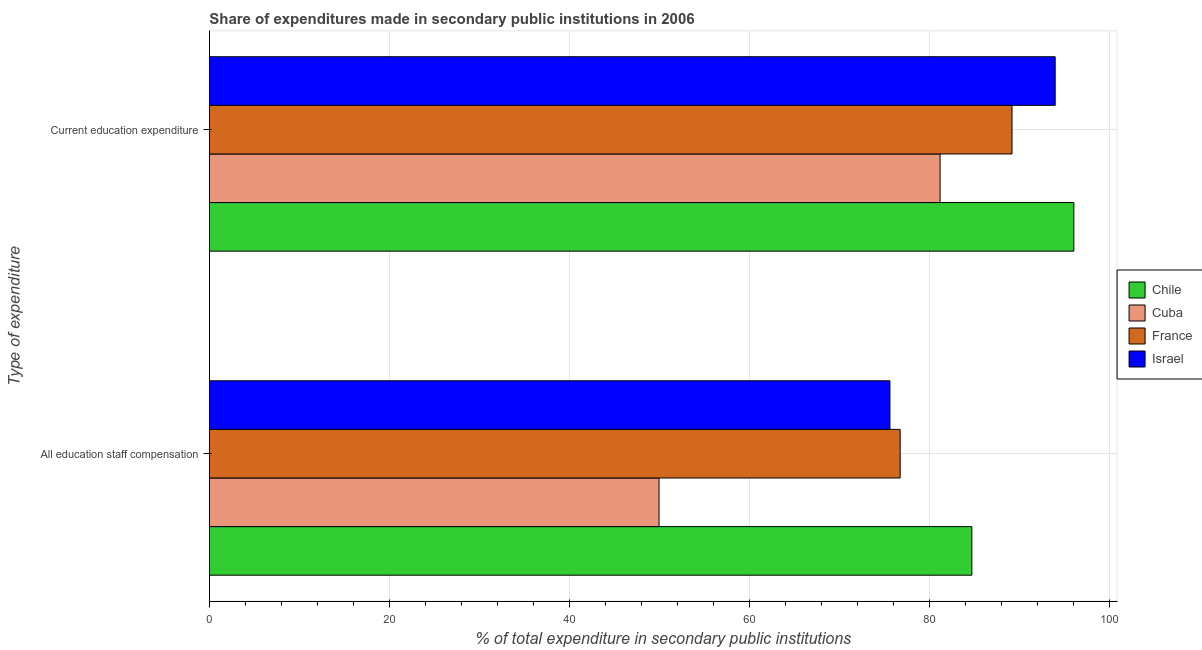How many different coloured bars are there?
Ensure brevity in your answer.  4. What is the label of the 2nd group of bars from the top?
Make the answer very short. All education staff compensation. What is the expenditure in staff compensation in Chile?
Give a very brief answer. 84.73. Across all countries, what is the maximum expenditure in staff compensation?
Provide a short and direct response. 84.73. Across all countries, what is the minimum expenditure in education?
Your response must be concise. 81.2. In which country was the expenditure in education maximum?
Ensure brevity in your answer.  Chile. In which country was the expenditure in staff compensation minimum?
Ensure brevity in your answer.  Cuba. What is the total expenditure in education in the graph?
Ensure brevity in your answer.  360.45. What is the difference between the expenditure in education in France and that in Cuba?
Your answer should be compact. 7.99. What is the difference between the expenditure in staff compensation in Israel and the expenditure in education in Cuba?
Your answer should be compact. -5.57. What is the average expenditure in education per country?
Keep it short and to the point. 90.11. What is the difference between the expenditure in staff compensation and expenditure in education in Israel?
Your answer should be compact. -18.36. In how many countries, is the expenditure in education greater than 16 %?
Your answer should be very brief. 4. What is the ratio of the expenditure in staff compensation in France to that in Cuba?
Provide a succinct answer. 1.54. Is the expenditure in staff compensation in Cuba less than that in Chile?
Make the answer very short. Yes. What does the 2nd bar from the bottom in Current education expenditure represents?
Offer a terse response. Cuba. How many bars are there?
Offer a terse response. 8. Are all the bars in the graph horizontal?
Offer a very short reply. Yes. What is the difference between two consecutive major ticks on the X-axis?
Your answer should be very brief. 20. Are the values on the major ticks of X-axis written in scientific E-notation?
Your answer should be compact. No. Does the graph contain any zero values?
Ensure brevity in your answer.  No. Does the graph contain grids?
Offer a terse response. Yes. How many legend labels are there?
Provide a short and direct response. 4. How are the legend labels stacked?
Ensure brevity in your answer.  Vertical. What is the title of the graph?
Ensure brevity in your answer.  Share of expenditures made in secondary public institutions in 2006. Does "St. Kitts and Nevis" appear as one of the legend labels in the graph?
Ensure brevity in your answer.  No. What is the label or title of the X-axis?
Provide a succinct answer. % of total expenditure in secondary public institutions. What is the label or title of the Y-axis?
Keep it short and to the point. Type of expenditure. What is the % of total expenditure in secondary public institutions of Chile in All education staff compensation?
Your answer should be compact. 84.73. What is the % of total expenditure in secondary public institutions in Cuba in All education staff compensation?
Your answer should be very brief. 49.97. What is the % of total expenditure in secondary public institutions in France in All education staff compensation?
Provide a short and direct response. 76.76. What is the % of total expenditure in secondary public institutions of Israel in All education staff compensation?
Offer a very short reply. 75.63. What is the % of total expenditure in secondary public institutions in Chile in Current education expenditure?
Your response must be concise. 96.07. What is the % of total expenditure in secondary public institutions in Cuba in Current education expenditure?
Provide a short and direct response. 81.2. What is the % of total expenditure in secondary public institutions in France in Current education expenditure?
Keep it short and to the point. 89.19. What is the % of total expenditure in secondary public institutions in Israel in Current education expenditure?
Offer a very short reply. 93.99. Across all Type of expenditure, what is the maximum % of total expenditure in secondary public institutions of Chile?
Give a very brief answer. 96.07. Across all Type of expenditure, what is the maximum % of total expenditure in secondary public institutions in Cuba?
Your answer should be compact. 81.2. Across all Type of expenditure, what is the maximum % of total expenditure in secondary public institutions in France?
Offer a terse response. 89.19. Across all Type of expenditure, what is the maximum % of total expenditure in secondary public institutions in Israel?
Offer a terse response. 93.99. Across all Type of expenditure, what is the minimum % of total expenditure in secondary public institutions of Chile?
Give a very brief answer. 84.73. Across all Type of expenditure, what is the minimum % of total expenditure in secondary public institutions of Cuba?
Your answer should be very brief. 49.97. Across all Type of expenditure, what is the minimum % of total expenditure in secondary public institutions of France?
Provide a succinct answer. 76.76. Across all Type of expenditure, what is the minimum % of total expenditure in secondary public institutions in Israel?
Make the answer very short. 75.63. What is the total % of total expenditure in secondary public institutions of Chile in the graph?
Give a very brief answer. 180.8. What is the total % of total expenditure in secondary public institutions of Cuba in the graph?
Your answer should be compact. 131.16. What is the total % of total expenditure in secondary public institutions in France in the graph?
Provide a short and direct response. 165.95. What is the total % of total expenditure in secondary public institutions of Israel in the graph?
Provide a short and direct response. 169.62. What is the difference between the % of total expenditure in secondary public institutions in Chile in All education staff compensation and that in Current education expenditure?
Your response must be concise. -11.34. What is the difference between the % of total expenditure in secondary public institutions in Cuba in All education staff compensation and that in Current education expenditure?
Your response must be concise. -31.23. What is the difference between the % of total expenditure in secondary public institutions of France in All education staff compensation and that in Current education expenditure?
Make the answer very short. -12.43. What is the difference between the % of total expenditure in secondary public institutions in Israel in All education staff compensation and that in Current education expenditure?
Provide a succinct answer. -18.36. What is the difference between the % of total expenditure in secondary public institutions of Chile in All education staff compensation and the % of total expenditure in secondary public institutions of Cuba in Current education expenditure?
Give a very brief answer. 3.53. What is the difference between the % of total expenditure in secondary public institutions in Chile in All education staff compensation and the % of total expenditure in secondary public institutions in France in Current education expenditure?
Give a very brief answer. -4.46. What is the difference between the % of total expenditure in secondary public institutions of Chile in All education staff compensation and the % of total expenditure in secondary public institutions of Israel in Current education expenditure?
Provide a succinct answer. -9.26. What is the difference between the % of total expenditure in secondary public institutions in Cuba in All education staff compensation and the % of total expenditure in secondary public institutions in France in Current education expenditure?
Provide a succinct answer. -39.23. What is the difference between the % of total expenditure in secondary public institutions of Cuba in All education staff compensation and the % of total expenditure in secondary public institutions of Israel in Current education expenditure?
Provide a succinct answer. -44.03. What is the difference between the % of total expenditure in secondary public institutions of France in All education staff compensation and the % of total expenditure in secondary public institutions of Israel in Current education expenditure?
Offer a terse response. -17.23. What is the average % of total expenditure in secondary public institutions in Chile per Type of expenditure?
Give a very brief answer. 90.4. What is the average % of total expenditure in secondary public institutions of Cuba per Type of expenditure?
Offer a terse response. 65.58. What is the average % of total expenditure in secondary public institutions in France per Type of expenditure?
Your response must be concise. 82.98. What is the average % of total expenditure in secondary public institutions in Israel per Type of expenditure?
Your response must be concise. 84.81. What is the difference between the % of total expenditure in secondary public institutions in Chile and % of total expenditure in secondary public institutions in Cuba in All education staff compensation?
Offer a very short reply. 34.76. What is the difference between the % of total expenditure in secondary public institutions in Chile and % of total expenditure in secondary public institutions in France in All education staff compensation?
Your response must be concise. 7.97. What is the difference between the % of total expenditure in secondary public institutions in Chile and % of total expenditure in secondary public institutions in Israel in All education staff compensation?
Make the answer very short. 9.1. What is the difference between the % of total expenditure in secondary public institutions of Cuba and % of total expenditure in secondary public institutions of France in All education staff compensation?
Keep it short and to the point. -26.8. What is the difference between the % of total expenditure in secondary public institutions in Cuba and % of total expenditure in secondary public institutions in Israel in All education staff compensation?
Keep it short and to the point. -25.66. What is the difference between the % of total expenditure in secondary public institutions of France and % of total expenditure in secondary public institutions of Israel in All education staff compensation?
Your answer should be compact. 1.13. What is the difference between the % of total expenditure in secondary public institutions of Chile and % of total expenditure in secondary public institutions of Cuba in Current education expenditure?
Provide a succinct answer. 14.87. What is the difference between the % of total expenditure in secondary public institutions of Chile and % of total expenditure in secondary public institutions of France in Current education expenditure?
Offer a very short reply. 6.87. What is the difference between the % of total expenditure in secondary public institutions of Chile and % of total expenditure in secondary public institutions of Israel in Current education expenditure?
Ensure brevity in your answer.  2.07. What is the difference between the % of total expenditure in secondary public institutions in Cuba and % of total expenditure in secondary public institutions in France in Current education expenditure?
Your answer should be very brief. -7.99. What is the difference between the % of total expenditure in secondary public institutions in Cuba and % of total expenditure in secondary public institutions in Israel in Current education expenditure?
Provide a succinct answer. -12.79. What is the difference between the % of total expenditure in secondary public institutions of France and % of total expenditure in secondary public institutions of Israel in Current education expenditure?
Make the answer very short. -4.8. What is the ratio of the % of total expenditure in secondary public institutions of Chile in All education staff compensation to that in Current education expenditure?
Your answer should be compact. 0.88. What is the ratio of the % of total expenditure in secondary public institutions of Cuba in All education staff compensation to that in Current education expenditure?
Offer a very short reply. 0.62. What is the ratio of the % of total expenditure in secondary public institutions of France in All education staff compensation to that in Current education expenditure?
Offer a terse response. 0.86. What is the ratio of the % of total expenditure in secondary public institutions of Israel in All education staff compensation to that in Current education expenditure?
Your response must be concise. 0.8. What is the difference between the highest and the second highest % of total expenditure in secondary public institutions of Chile?
Your response must be concise. 11.34. What is the difference between the highest and the second highest % of total expenditure in secondary public institutions of Cuba?
Provide a short and direct response. 31.23. What is the difference between the highest and the second highest % of total expenditure in secondary public institutions of France?
Provide a short and direct response. 12.43. What is the difference between the highest and the second highest % of total expenditure in secondary public institutions of Israel?
Ensure brevity in your answer.  18.36. What is the difference between the highest and the lowest % of total expenditure in secondary public institutions in Chile?
Keep it short and to the point. 11.34. What is the difference between the highest and the lowest % of total expenditure in secondary public institutions in Cuba?
Make the answer very short. 31.23. What is the difference between the highest and the lowest % of total expenditure in secondary public institutions of France?
Give a very brief answer. 12.43. What is the difference between the highest and the lowest % of total expenditure in secondary public institutions of Israel?
Make the answer very short. 18.36. 